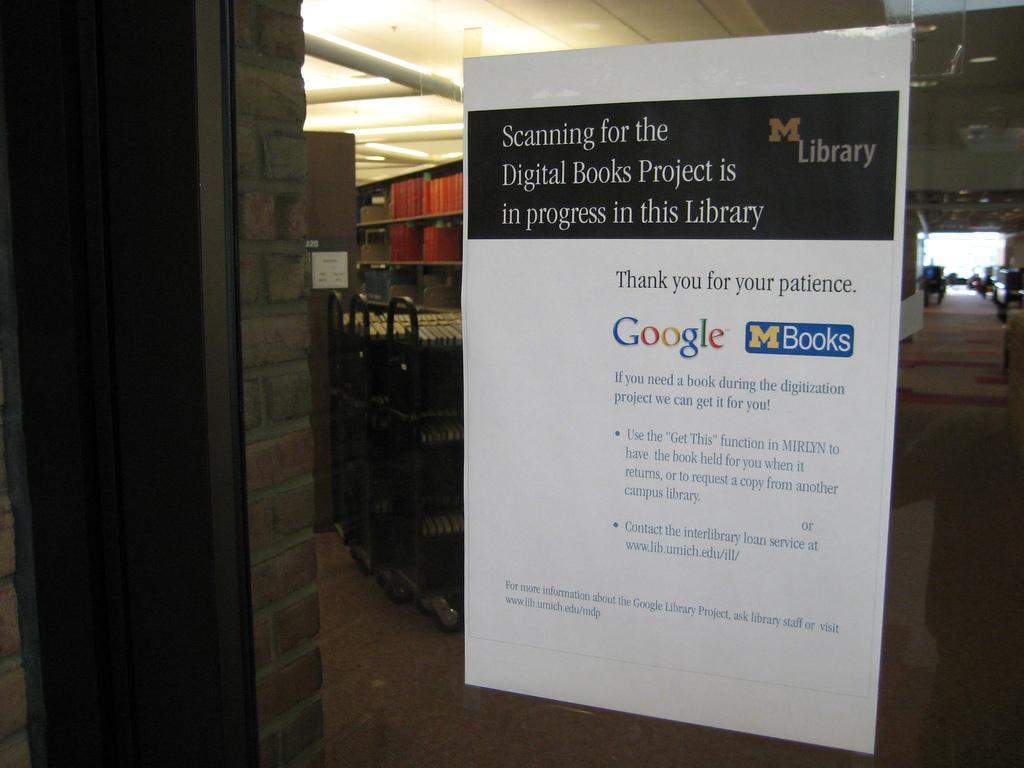Provide a one-sentence caption for the provided image. The library is hosting a project to use digital books. 